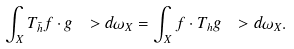Convert formula to latex. <formula><loc_0><loc_0><loc_500><loc_500>\int _ { X } T _ { \bar { h } } f \cdot g \ > d \omega _ { X } = \int _ { X } f \cdot T _ { h } g \ > d \omega _ { X } .</formula> 